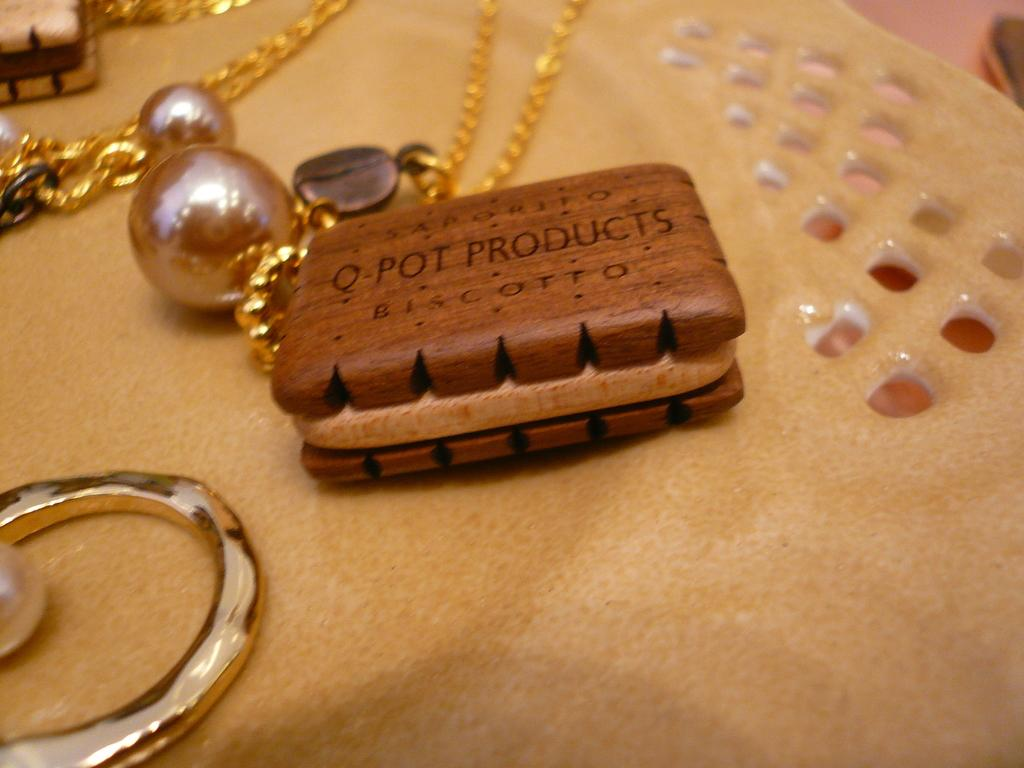What are the two wooden objects in the foreground of the image? There are two wooden objects in the foreground of the image. How are the wooden objects connected? There is a chain attached to the wooden objects. What is hanging from the chain? There are balls on the chain. What is the shape of the structure at the bottom of the chain? There is a ring-like structure at the bottom of the chain. What is the color of the object mentioned? The cream color object is present in the image. What type of food is being served on the plate in the image? There is no plate or food present in the image. What kind of cracker is visible in the image? There are no crackers present in the image. 